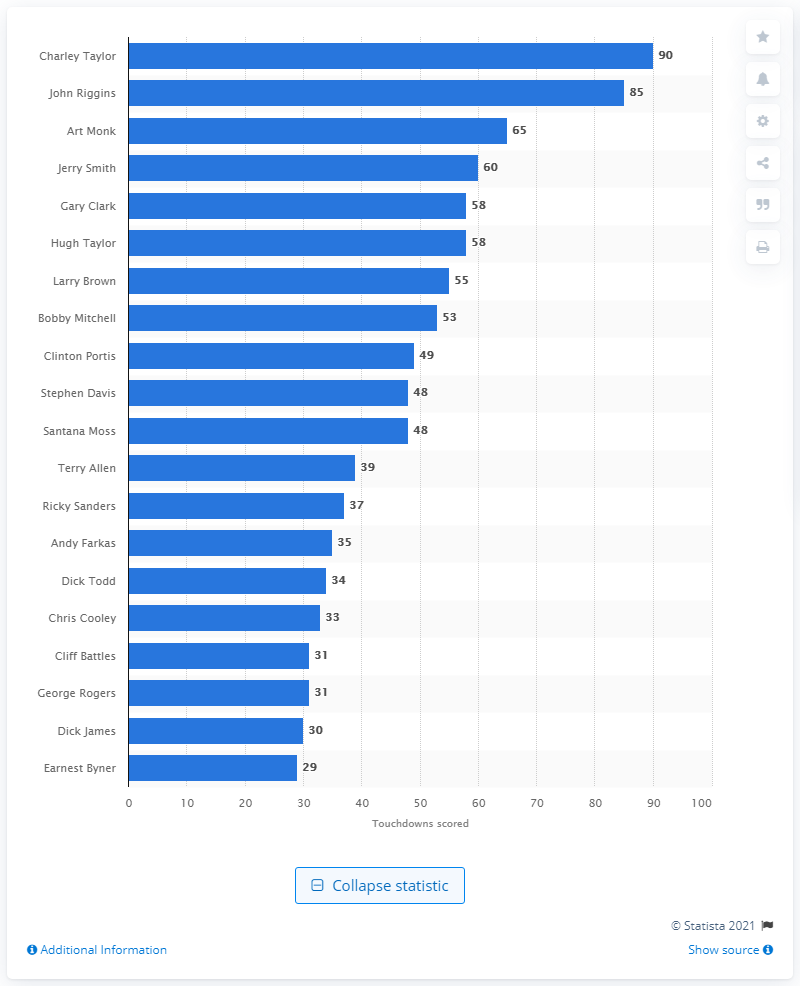Point out several critical features in this image. The career touchdown leader of the Washington Football Team is Charley Taylor. Charley Taylor has scored a total of 90 touchdowns. 